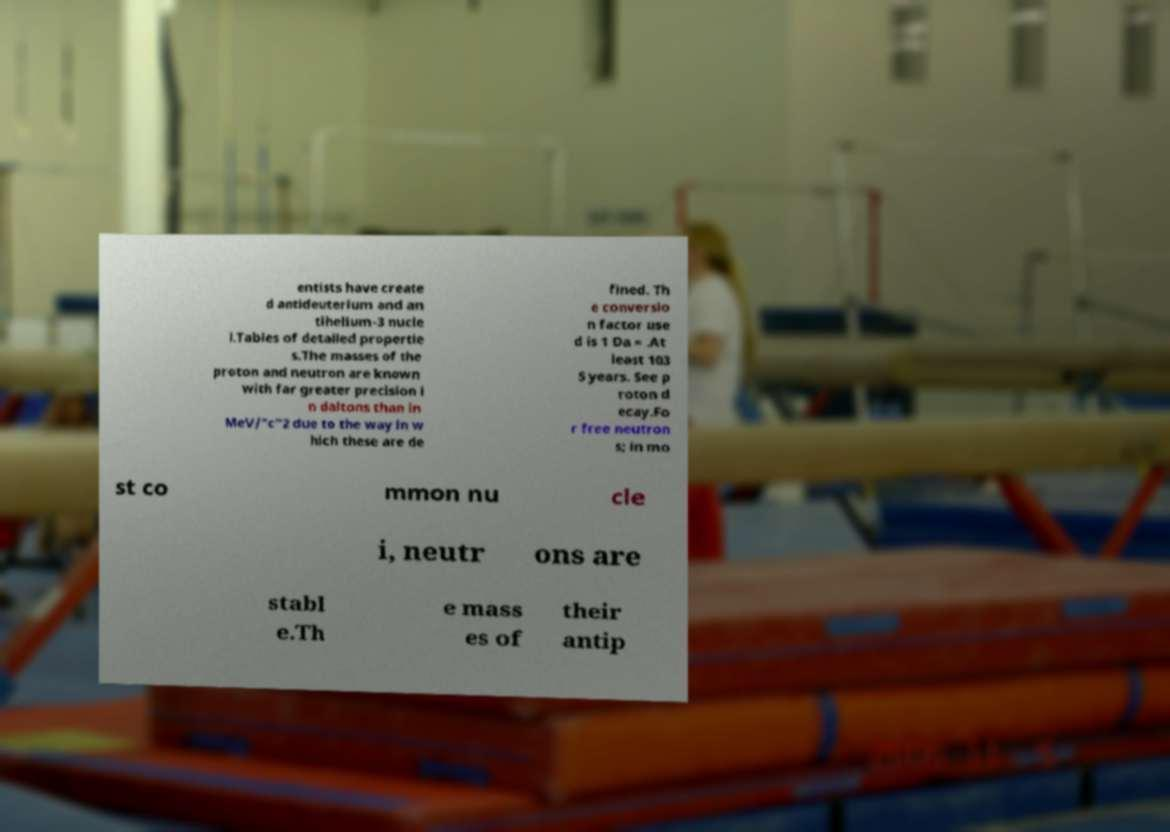Could you assist in decoding the text presented in this image and type it out clearly? entists have create d antideuterium and an tihelium-3 nucle i.Tables of detailed propertie s.The masses of the proton and neutron are known with far greater precision i n daltons than in MeV/"c"2 due to the way in w hich these are de fined. Th e conversio n factor use d is 1 Da = .At least 103 5 years. See p roton d ecay.Fo r free neutron s; in mo st co mmon nu cle i, neutr ons are stabl e.Th e mass es of their antip 